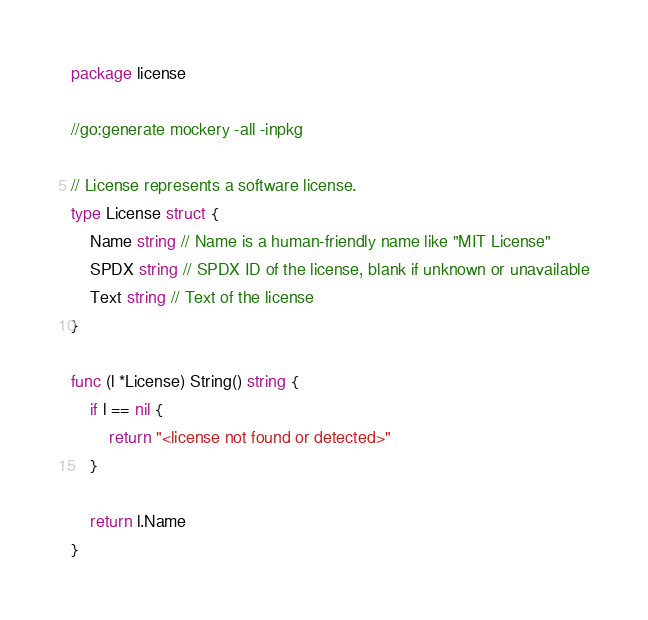<code> <loc_0><loc_0><loc_500><loc_500><_Go_>package license

//go:generate mockery -all -inpkg

// License represents a software license.
type License struct {
	Name string // Name is a human-friendly name like "MIT License"
	SPDX string // SPDX ID of the license, blank if unknown or unavailable
	Text string // Text of the license
}

func (l *License) String() string {
	if l == nil {
		return "<license not found or detected>"
	}

	return l.Name
}
</code> 